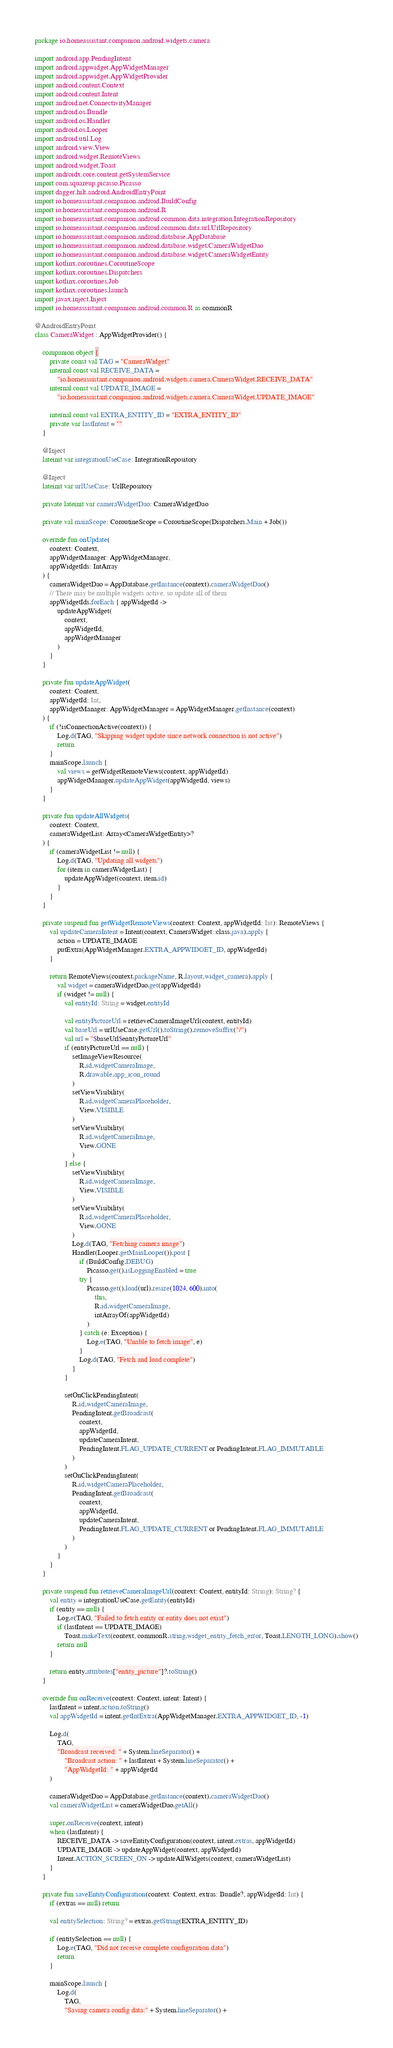Convert code to text. <code><loc_0><loc_0><loc_500><loc_500><_Kotlin_>package io.homeassistant.companion.android.widgets.camera

import android.app.PendingIntent
import android.appwidget.AppWidgetManager
import android.appwidget.AppWidgetProvider
import android.content.Context
import android.content.Intent
import android.net.ConnectivityManager
import android.os.Bundle
import android.os.Handler
import android.os.Looper
import android.util.Log
import android.view.View
import android.widget.RemoteViews
import android.widget.Toast
import androidx.core.content.getSystemService
import com.squareup.picasso.Picasso
import dagger.hilt.android.AndroidEntryPoint
import io.homeassistant.companion.android.BuildConfig
import io.homeassistant.companion.android.R
import io.homeassistant.companion.android.common.data.integration.IntegrationRepository
import io.homeassistant.companion.android.common.data.url.UrlRepository
import io.homeassistant.companion.android.database.AppDatabase
import io.homeassistant.companion.android.database.widget.CameraWidgetDao
import io.homeassistant.companion.android.database.widget.CameraWidgetEntity
import kotlinx.coroutines.CoroutineScope
import kotlinx.coroutines.Dispatchers
import kotlinx.coroutines.Job
import kotlinx.coroutines.launch
import javax.inject.Inject
import io.homeassistant.companion.android.common.R as commonR

@AndroidEntryPoint
class CameraWidget : AppWidgetProvider() {

    companion object {
        private const val TAG = "CameraWidget"
        internal const val RECEIVE_DATA =
            "io.homeassistant.companion.android.widgets.camera.CameraWidget.RECEIVE_DATA"
        internal const val UPDATE_IMAGE =
            "io.homeassistant.companion.android.widgets.camera.CameraWidget.UPDATE_IMAGE"

        internal const val EXTRA_ENTITY_ID = "EXTRA_ENTITY_ID"
        private var lastIntent = ""
    }

    @Inject
    lateinit var integrationUseCase: IntegrationRepository

    @Inject
    lateinit var urlUseCase: UrlRepository

    private lateinit var cameraWidgetDao: CameraWidgetDao

    private val mainScope: CoroutineScope = CoroutineScope(Dispatchers.Main + Job())

    override fun onUpdate(
        context: Context,
        appWidgetManager: AppWidgetManager,
        appWidgetIds: IntArray
    ) {
        cameraWidgetDao = AppDatabase.getInstance(context).cameraWidgetDao()
        // There may be multiple widgets active, so update all of them
        appWidgetIds.forEach { appWidgetId ->
            updateAppWidget(
                context,
                appWidgetId,
                appWidgetManager
            )
        }
    }

    private fun updateAppWidget(
        context: Context,
        appWidgetId: Int,
        appWidgetManager: AppWidgetManager = AppWidgetManager.getInstance(context)
    ) {
        if (!isConnectionActive(context)) {
            Log.d(TAG, "Skipping widget update since network connection is not active")
            return
        }
        mainScope.launch {
            val views = getWidgetRemoteViews(context, appWidgetId)
            appWidgetManager.updateAppWidget(appWidgetId, views)
        }
    }

    private fun updateAllWidgets(
        context: Context,
        cameraWidgetList: Array<CameraWidgetEntity>?
    ) {
        if (cameraWidgetList != null) {
            Log.d(TAG, "Updating all widgets")
            for (item in cameraWidgetList) {
                updateAppWidget(context, item.id)
            }
        }
    }

    private suspend fun getWidgetRemoteViews(context: Context, appWidgetId: Int): RemoteViews {
        val updateCameraIntent = Intent(context, CameraWidget::class.java).apply {
            action = UPDATE_IMAGE
            putExtra(AppWidgetManager.EXTRA_APPWIDGET_ID, appWidgetId)
        }

        return RemoteViews(context.packageName, R.layout.widget_camera).apply {
            val widget = cameraWidgetDao.get(appWidgetId)
            if (widget != null) {
                val entityId: String = widget.entityId

                val entityPictureUrl = retrieveCameraImageUrl(context, entityId)
                val baseUrl = urlUseCase.getUrl().toString().removeSuffix("/")
                val url = "$baseUrl$entityPictureUrl"
                if (entityPictureUrl == null) {
                    setImageViewResource(
                        R.id.widgetCameraImage,
                        R.drawable.app_icon_round
                    )
                    setViewVisibility(
                        R.id.widgetCameraPlaceholder,
                        View.VISIBLE
                    )
                    setViewVisibility(
                        R.id.widgetCameraImage,
                        View.GONE
                    )
                } else {
                    setViewVisibility(
                        R.id.widgetCameraImage,
                        View.VISIBLE
                    )
                    setViewVisibility(
                        R.id.widgetCameraPlaceholder,
                        View.GONE
                    )
                    Log.d(TAG, "Fetching camera image")
                    Handler(Looper.getMainLooper()).post {
                        if (BuildConfig.DEBUG)
                            Picasso.get().isLoggingEnabled = true
                        try {
                            Picasso.get().load(url).resize(1024, 600).into(
                                this,
                                R.id.widgetCameraImage,
                                intArrayOf(appWidgetId)
                            )
                        } catch (e: Exception) {
                            Log.e(TAG, "Unable to fetch image", e)
                        }
                        Log.d(TAG, "Fetch and load complete")
                    }
                }

                setOnClickPendingIntent(
                    R.id.widgetCameraImage,
                    PendingIntent.getBroadcast(
                        context,
                        appWidgetId,
                        updateCameraIntent,
                        PendingIntent.FLAG_UPDATE_CURRENT or PendingIntent.FLAG_IMMUTABLE
                    )
                )
                setOnClickPendingIntent(
                    R.id.widgetCameraPlaceholder,
                    PendingIntent.getBroadcast(
                        context,
                        appWidgetId,
                        updateCameraIntent,
                        PendingIntent.FLAG_UPDATE_CURRENT or PendingIntent.FLAG_IMMUTABLE
                    )
                )
            }
        }
    }

    private suspend fun retrieveCameraImageUrl(context: Context, entityId: String): String? {
        val entity = integrationUseCase.getEntity(entityId)
        if (entity == null) {
            Log.e(TAG, "Failed to fetch entity or entity does not exist")
            if (lastIntent == UPDATE_IMAGE)
                Toast.makeText(context, commonR.string.widget_entity_fetch_error, Toast.LENGTH_LONG).show()
            return null
        }

        return entity.attributes["entity_picture"]?.toString()
    }

    override fun onReceive(context: Context, intent: Intent) {
        lastIntent = intent.action.toString()
        val appWidgetId = intent.getIntExtra(AppWidgetManager.EXTRA_APPWIDGET_ID, -1)

        Log.d(
            TAG,
            "Broadcast received: " + System.lineSeparator() +
                "Broadcast action: " + lastIntent + System.lineSeparator() +
                "AppWidgetId: " + appWidgetId
        )

        cameraWidgetDao = AppDatabase.getInstance(context).cameraWidgetDao()
        val cameraWidgetList = cameraWidgetDao.getAll()

        super.onReceive(context, intent)
        when (lastIntent) {
            RECEIVE_DATA -> saveEntityConfiguration(context, intent.extras, appWidgetId)
            UPDATE_IMAGE -> updateAppWidget(context, appWidgetId)
            Intent.ACTION_SCREEN_ON -> updateAllWidgets(context, cameraWidgetList)
        }
    }

    private fun saveEntityConfiguration(context: Context, extras: Bundle?, appWidgetId: Int) {
        if (extras == null) return

        val entitySelection: String? = extras.getString(EXTRA_ENTITY_ID)

        if (entitySelection == null) {
            Log.e(TAG, "Did not receive complete configuration data")
            return
        }

        mainScope.launch {
            Log.d(
                TAG,
                "Saving camera config data:" + System.lineSeparator() +</code> 